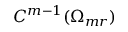<formula> <loc_0><loc_0><loc_500><loc_500>C ^ { m - 1 } ( \Omega _ { m r } )</formula> 